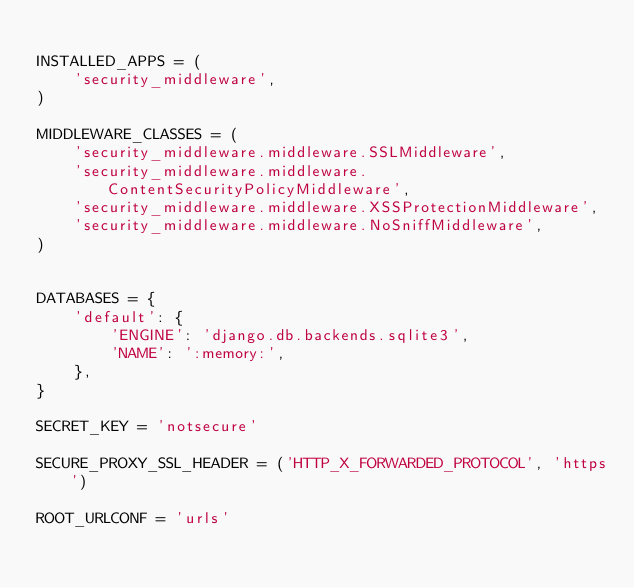<code> <loc_0><loc_0><loc_500><loc_500><_Python_>
INSTALLED_APPS = (
    'security_middleware',
)

MIDDLEWARE_CLASSES = (
    'security_middleware.middleware.SSLMiddleware',
    'security_middleware.middleware.ContentSecurityPolicyMiddleware',
    'security_middleware.middleware.XSSProtectionMiddleware',
    'security_middleware.middleware.NoSniffMiddleware',
)


DATABASES = {
    'default': {
        'ENGINE': 'django.db.backends.sqlite3',
        'NAME': ':memory:',
    },
}

SECRET_KEY = 'notsecure'

SECURE_PROXY_SSL_HEADER = ('HTTP_X_FORWARDED_PROTOCOL', 'https')

ROOT_URLCONF = 'urls'
</code> 